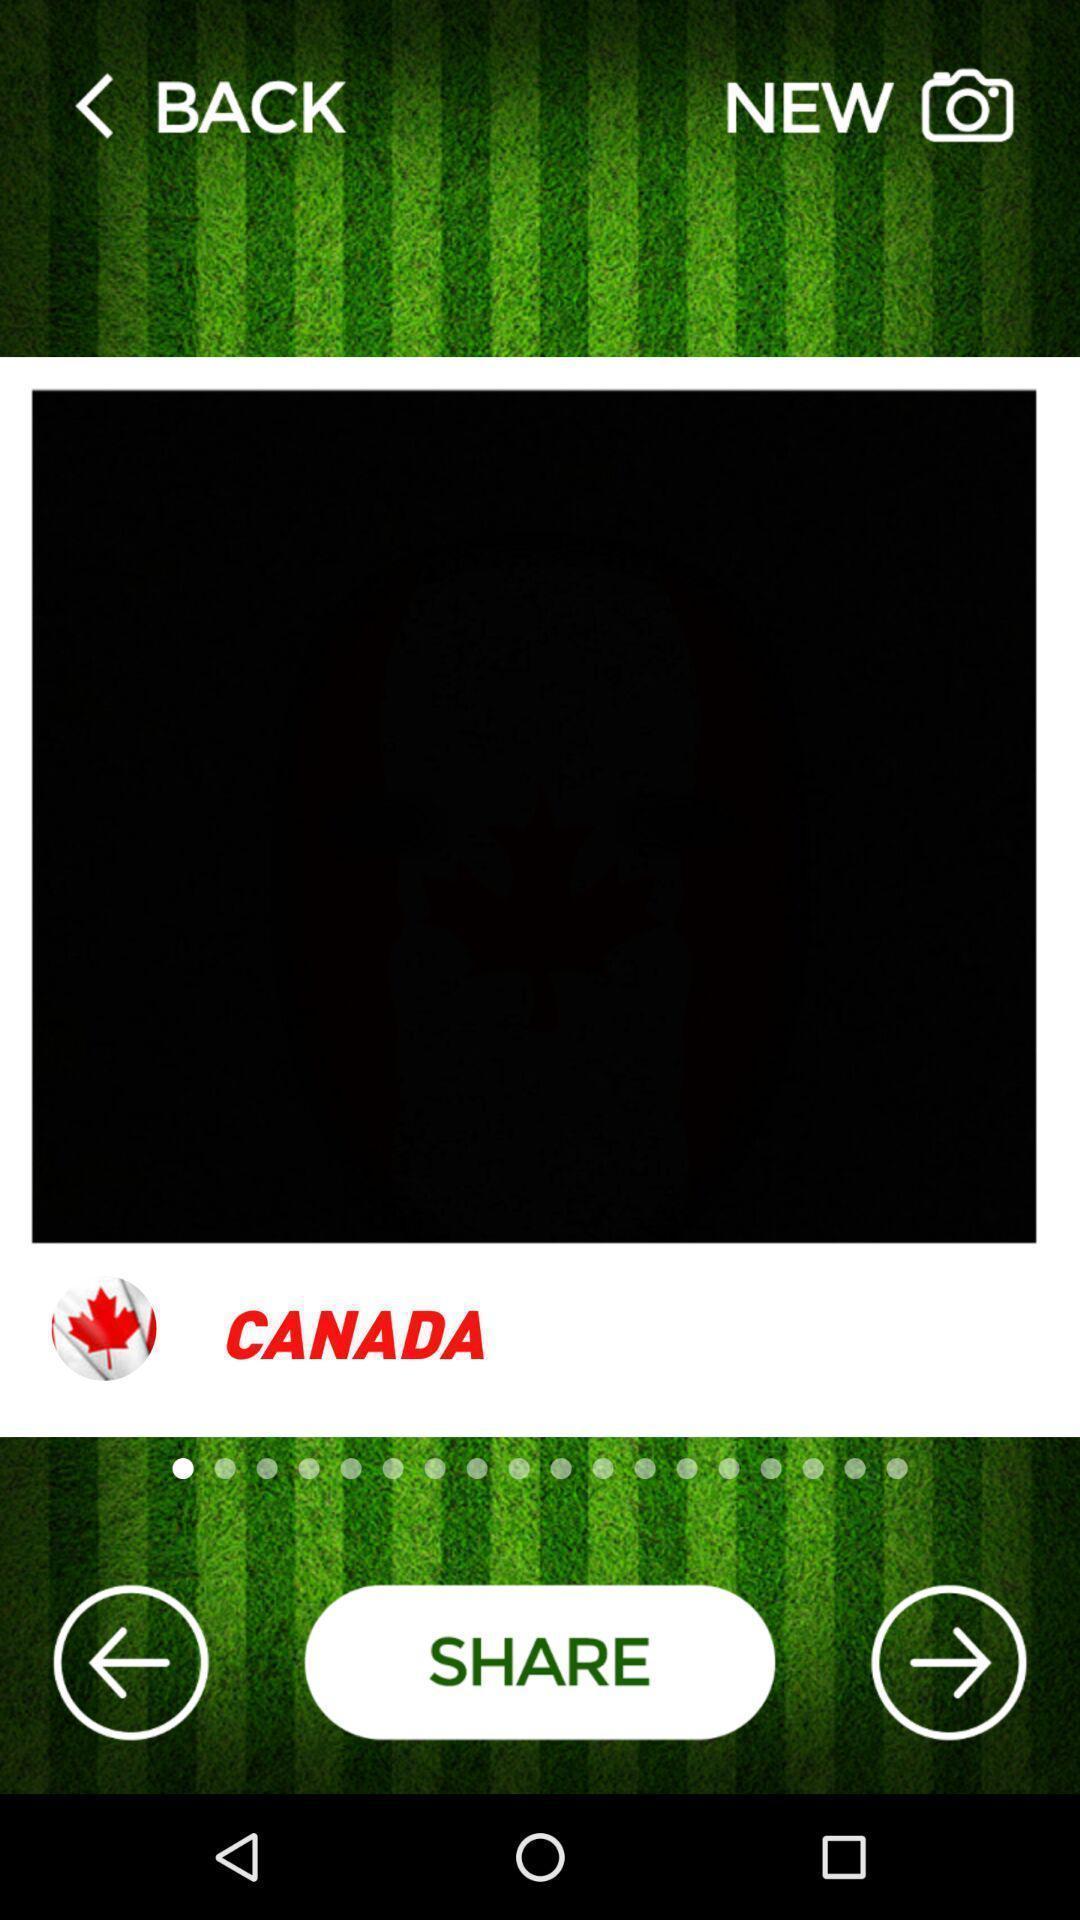Summarize the information in this screenshot. Screen showing page with share option. 